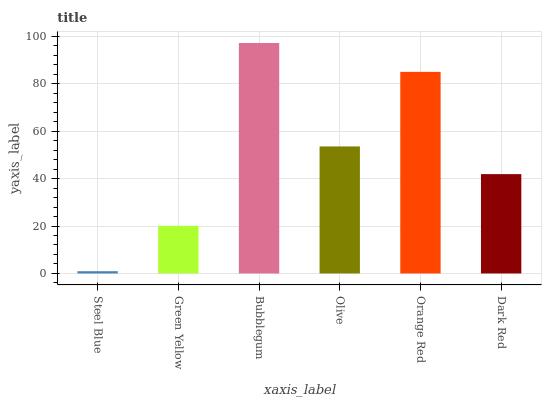Is Steel Blue the minimum?
Answer yes or no. Yes. Is Bubblegum the maximum?
Answer yes or no. Yes. Is Green Yellow the minimum?
Answer yes or no. No. Is Green Yellow the maximum?
Answer yes or no. No. Is Green Yellow greater than Steel Blue?
Answer yes or no. Yes. Is Steel Blue less than Green Yellow?
Answer yes or no. Yes. Is Steel Blue greater than Green Yellow?
Answer yes or no. No. Is Green Yellow less than Steel Blue?
Answer yes or no. No. Is Olive the high median?
Answer yes or no. Yes. Is Dark Red the low median?
Answer yes or no. Yes. Is Bubblegum the high median?
Answer yes or no. No. Is Green Yellow the low median?
Answer yes or no. No. 